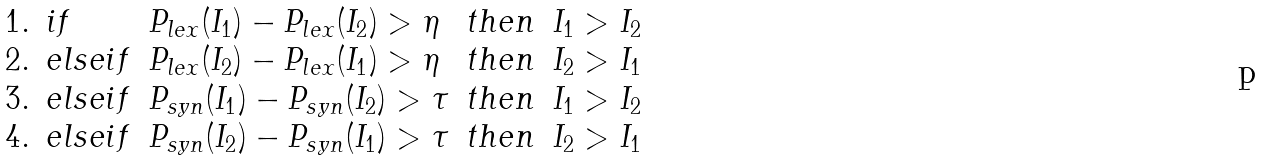<formula> <loc_0><loc_0><loc_500><loc_500>\begin{array} { l l l l l } 1 . & i f & P _ { l e x } ( I _ { 1 } ) - P _ { l e x } ( I _ { 2 } ) > \eta & t h e n & I _ { 1 } > I _ { 2 } \\ 2 . & e l s e i f & P _ { l e x } ( I _ { 2 } ) - P _ { l e x } ( I _ { 1 } ) > \eta & t h e n & I _ { 2 } > I _ { 1 } \\ 3 . & e l s e i f & P _ { s y n } ( I _ { 1 } ) - P _ { s y n } ( I _ { 2 } ) > \tau & t h e n & I _ { 1 } > I _ { 2 } \\ 4 . & e l s e i f & P _ { s y n } ( I _ { 2 } ) - P _ { s y n } ( I _ { 1 } ) > \tau & t h e n & I _ { 2 } > I _ { 1 } \\ \end{array}</formula> 